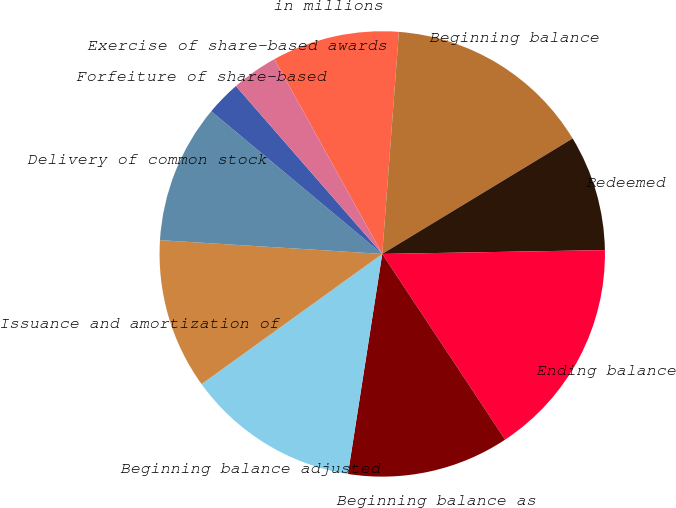<chart> <loc_0><loc_0><loc_500><loc_500><pie_chart><fcel>in millions<fcel>Beginning balance<fcel>Redeemed<fcel>Ending balance<fcel>Beginning balance as<fcel>Beginning balance adjusted<fcel>Issuance and amortization of<fcel>Delivery of common stock<fcel>Forfeiture of share-based<fcel>Exercise of share-based awards<nl><fcel>9.24%<fcel>15.13%<fcel>8.4%<fcel>15.97%<fcel>11.76%<fcel>12.6%<fcel>10.92%<fcel>10.08%<fcel>2.52%<fcel>3.36%<nl></chart> 